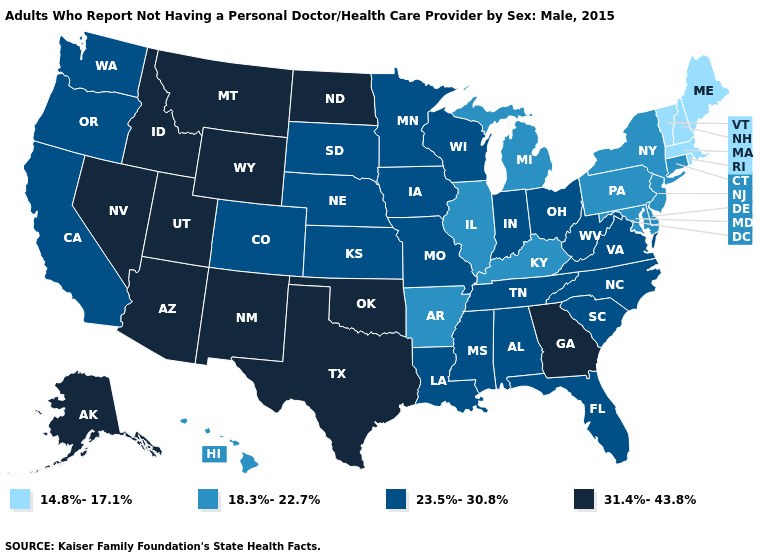Name the states that have a value in the range 18.3%-22.7%?
Quick response, please. Arkansas, Connecticut, Delaware, Hawaii, Illinois, Kentucky, Maryland, Michigan, New Jersey, New York, Pennsylvania. Among the states that border Nebraska , which have the lowest value?
Give a very brief answer. Colorado, Iowa, Kansas, Missouri, South Dakota. What is the value of Connecticut?
Quick response, please. 18.3%-22.7%. Does Kansas have the same value as West Virginia?
Be succinct. Yes. Does North Carolina have a higher value than Georgia?
Short answer required. No. What is the value of Indiana?
Keep it brief. 23.5%-30.8%. What is the lowest value in the Northeast?
Keep it brief. 14.8%-17.1%. Does West Virginia have the same value as Delaware?
Short answer required. No. What is the lowest value in states that border Rhode Island?
Give a very brief answer. 14.8%-17.1%. What is the lowest value in the USA?
Be succinct. 14.8%-17.1%. Which states have the highest value in the USA?
Short answer required. Alaska, Arizona, Georgia, Idaho, Montana, Nevada, New Mexico, North Dakota, Oklahoma, Texas, Utah, Wyoming. How many symbols are there in the legend?
Concise answer only. 4. Name the states that have a value in the range 23.5%-30.8%?
Concise answer only. Alabama, California, Colorado, Florida, Indiana, Iowa, Kansas, Louisiana, Minnesota, Mississippi, Missouri, Nebraska, North Carolina, Ohio, Oregon, South Carolina, South Dakota, Tennessee, Virginia, Washington, West Virginia, Wisconsin. Which states have the lowest value in the USA?
Give a very brief answer. Maine, Massachusetts, New Hampshire, Rhode Island, Vermont. What is the highest value in states that border Texas?
Short answer required. 31.4%-43.8%. 